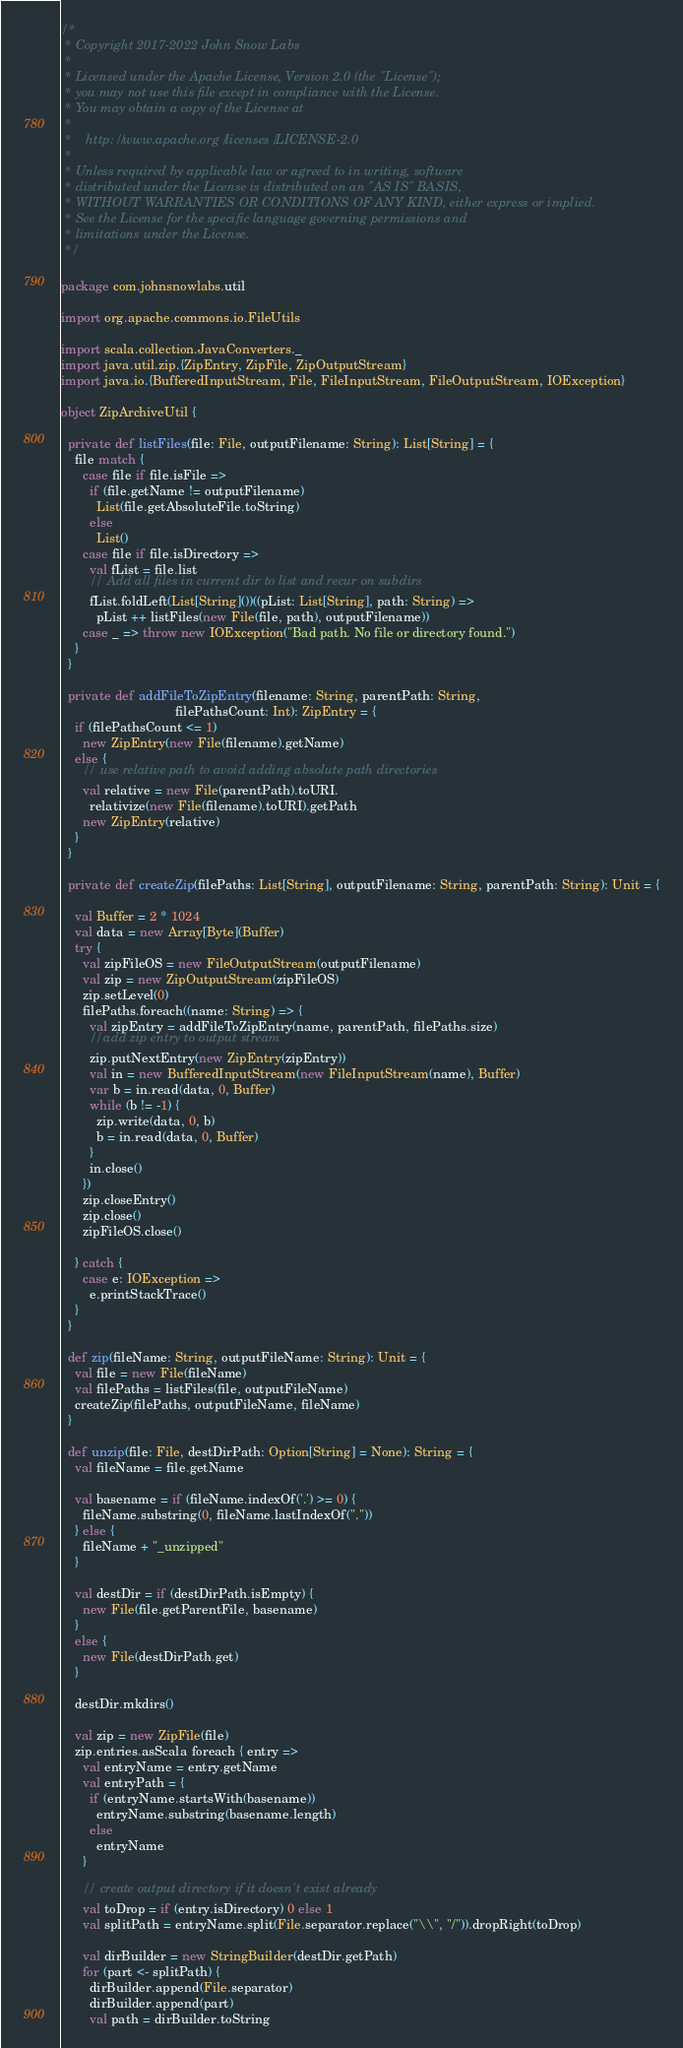<code> <loc_0><loc_0><loc_500><loc_500><_Scala_>/*
 * Copyright 2017-2022 John Snow Labs
 *
 * Licensed under the Apache License, Version 2.0 (the "License");
 * you may not use this file except in compliance with the License.
 * You may obtain a copy of the License at
 *
 *    http://www.apache.org/licenses/LICENSE-2.0
 *
 * Unless required by applicable law or agreed to in writing, software
 * distributed under the License is distributed on an "AS IS" BASIS,
 * WITHOUT WARRANTIES OR CONDITIONS OF ANY KIND, either express or implied.
 * See the License for the specific language governing permissions and
 * limitations under the License.
 */

package com.johnsnowlabs.util

import org.apache.commons.io.FileUtils

import scala.collection.JavaConverters._
import java.util.zip.{ZipEntry, ZipFile, ZipOutputStream}
import java.io.{BufferedInputStream, File, FileInputStream, FileOutputStream, IOException}

object ZipArchiveUtil {

  private def listFiles(file: File, outputFilename: String): List[String] = {
    file match {
      case file if file.isFile =>
        if (file.getName != outputFilename)
          List(file.getAbsoluteFile.toString)
        else
          List()
      case file if file.isDirectory =>
        val fList = file.list
        // Add all files in current dir to list and recur on subdirs
        fList.foldLeft(List[String]())((pList: List[String], path: String) =>
          pList ++ listFiles(new File(file, path), outputFilename))
      case _ => throw new IOException("Bad path. No file or directory found.")
    }
  }

  private def addFileToZipEntry(filename: String, parentPath: String,
                                filePathsCount: Int): ZipEntry = {
    if (filePathsCount <= 1)
      new ZipEntry(new File(filename).getName)
    else {
      // use relative path to avoid adding absolute path directories
      val relative = new File(parentPath).toURI.
        relativize(new File(filename).toURI).getPath
      new ZipEntry(relative)
    }
  }

  private def createZip(filePaths: List[String], outputFilename: String, parentPath: String): Unit = {

    val Buffer = 2 * 1024
    val data = new Array[Byte](Buffer)
    try {
      val zipFileOS = new FileOutputStream(outputFilename)
      val zip = new ZipOutputStream(zipFileOS)
      zip.setLevel(0)
      filePaths.foreach((name: String) => {
        val zipEntry = addFileToZipEntry(name, parentPath, filePaths.size)
        //add zip entry to output stream
        zip.putNextEntry(new ZipEntry(zipEntry))
        val in = new BufferedInputStream(new FileInputStream(name), Buffer)
        var b = in.read(data, 0, Buffer)
        while (b != -1) {
          zip.write(data, 0, b)
          b = in.read(data, 0, Buffer)
        }
        in.close()
      })
      zip.closeEntry()
      zip.close()
      zipFileOS.close()

    } catch {
      case e: IOException =>
        e.printStackTrace()
    }
  }

  def zip(fileName: String, outputFileName: String): Unit = {
    val file = new File(fileName)
    val filePaths = listFiles(file, outputFileName)
    createZip(filePaths, outputFileName, fileName)
  }

  def unzip(file: File, destDirPath: Option[String] = None): String = {
    val fileName = file.getName

    val basename = if (fileName.indexOf('.') >= 0) {
      fileName.substring(0, fileName.lastIndexOf("."))
    } else {
      fileName + "_unzipped"
    }

    val destDir = if (destDirPath.isEmpty) {
      new File(file.getParentFile, basename)
    }
    else {
      new File(destDirPath.get)
    }

    destDir.mkdirs()

    val zip = new ZipFile(file)
    zip.entries.asScala foreach { entry =>
      val entryName = entry.getName
      val entryPath = {
        if (entryName.startsWith(basename))
          entryName.substring(basename.length)
        else
          entryName
      }

      // create output directory if it doesn't exist already
      val toDrop = if (entry.isDirectory) 0 else 1
      val splitPath = entryName.split(File.separator.replace("\\", "/")).dropRight(toDrop)

      val dirBuilder = new StringBuilder(destDir.getPath)
      for (part <- splitPath) {
        dirBuilder.append(File.separator)
        dirBuilder.append(part)
        val path = dirBuilder.toString
</code> 